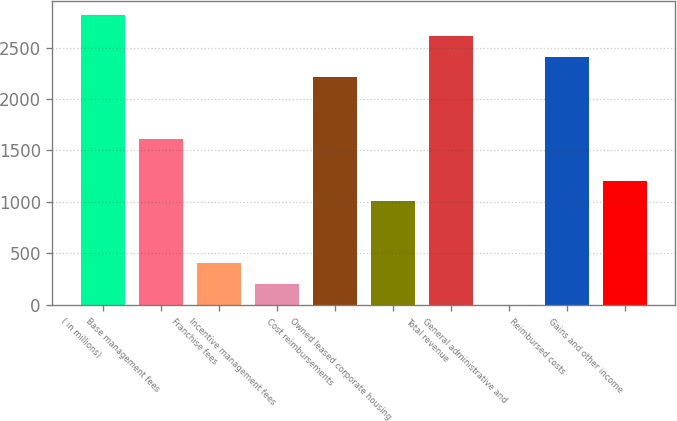Convert chart. <chart><loc_0><loc_0><loc_500><loc_500><bar_chart><fcel>( in millions)<fcel>Base management fees<fcel>Franchise fees<fcel>Incentive management fees<fcel>Cost reimbursements<fcel>Owned leased corporate housing<fcel>Total revenue<fcel>General administrative and<fcel>Reimbursed costs<fcel>Gains and other income<nl><fcel>2812.2<fcel>1607.4<fcel>402.6<fcel>201.8<fcel>2209.8<fcel>1005<fcel>2611.4<fcel>1<fcel>2410.6<fcel>1205.8<nl></chart> 